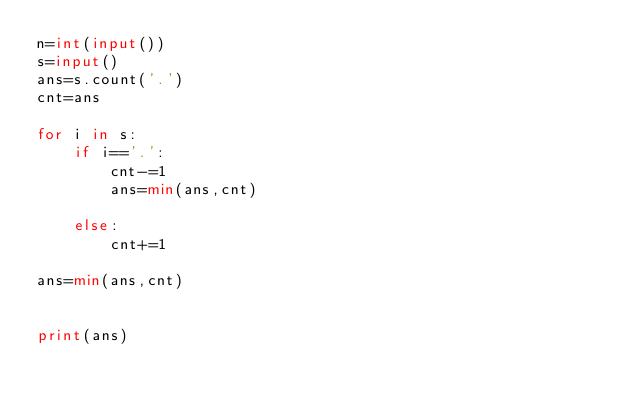Convert code to text. <code><loc_0><loc_0><loc_500><loc_500><_Python_>n=int(input())
s=input()
ans=s.count('.')
cnt=ans

for i in s:
    if i=='.':
        cnt-=1
        ans=min(ans,cnt)
    
    else:
        cnt+=1

ans=min(ans,cnt)


print(ans)</code> 